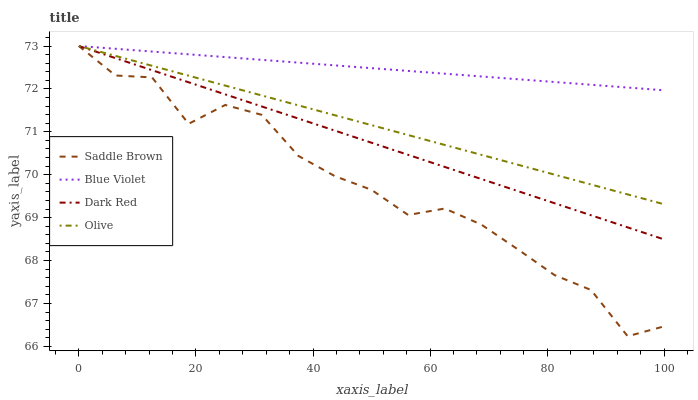Does Saddle Brown have the minimum area under the curve?
Answer yes or no. Yes. Does Blue Violet have the maximum area under the curve?
Answer yes or no. Yes. Does Dark Red have the minimum area under the curve?
Answer yes or no. No. Does Dark Red have the maximum area under the curve?
Answer yes or no. No. Is Olive the smoothest?
Answer yes or no. Yes. Is Saddle Brown the roughest?
Answer yes or no. Yes. Is Dark Red the smoothest?
Answer yes or no. No. Is Dark Red the roughest?
Answer yes or no. No. Does Dark Red have the lowest value?
Answer yes or no. No. Does Blue Violet have the highest value?
Answer yes or no. Yes. Does Dark Red intersect Saddle Brown?
Answer yes or no. Yes. Is Dark Red less than Saddle Brown?
Answer yes or no. No. Is Dark Red greater than Saddle Brown?
Answer yes or no. No. 